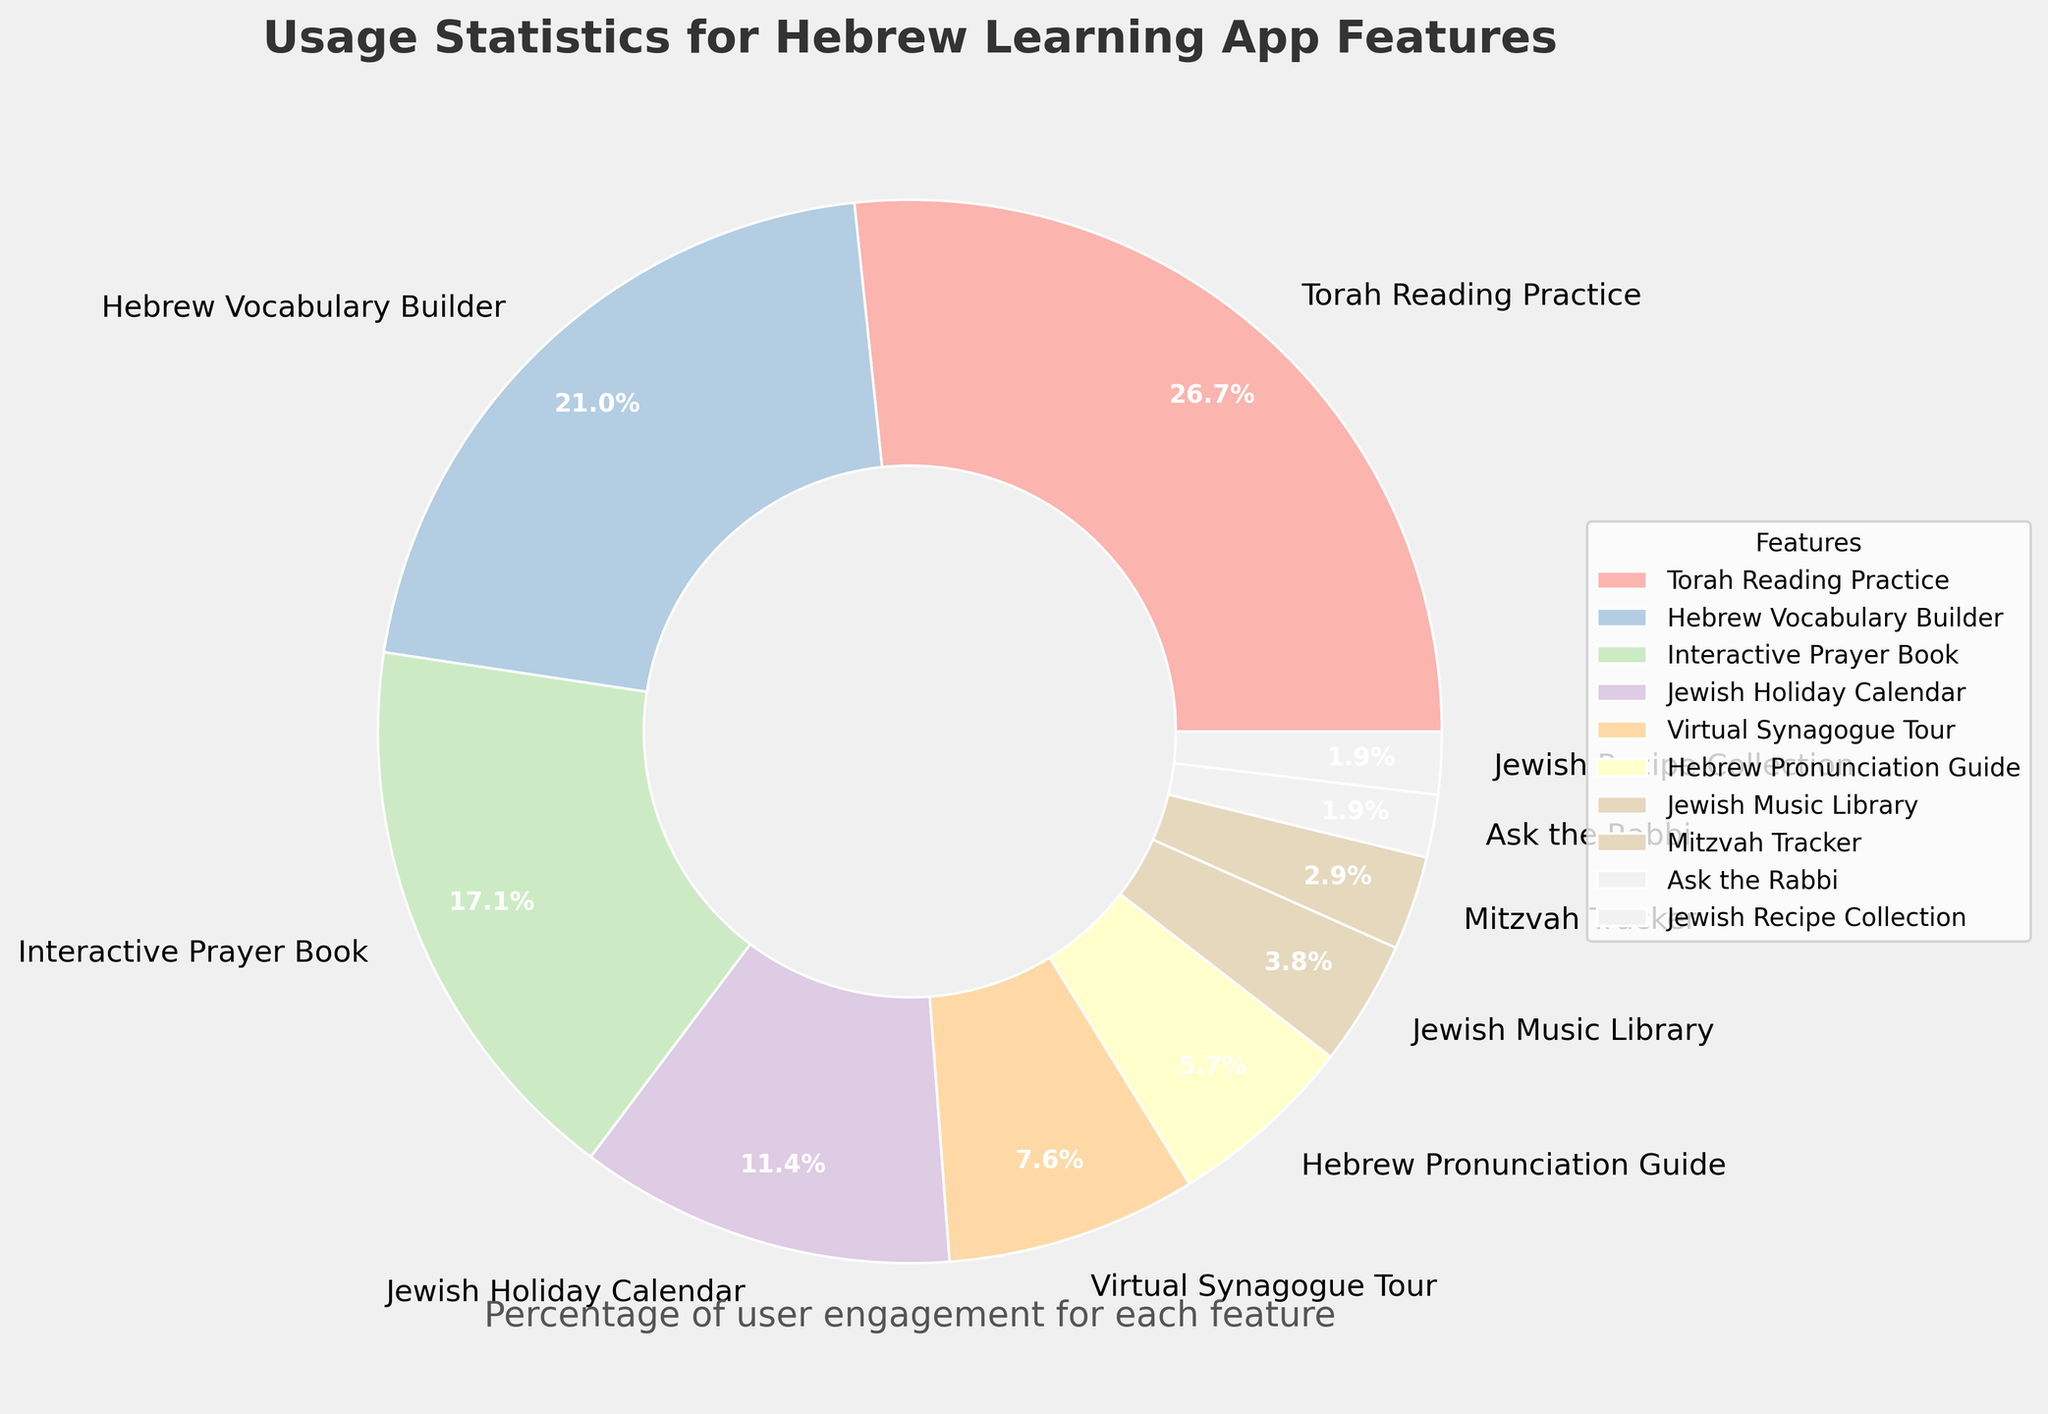Which feature has the highest percentage of user engagement? The feature with the largest slice in the pie chart represents the highest percentage of user engagement.
Answer: Torah Reading Practice Which feature has the lowest percentage of user engagement? The feature with the smallest slice in the pie chart represents the lowest percentage of user engagement.
Answer: Ask the Rabbi, Jewish Recipe Collection How much more usage does the Hebrew Vocabulary Builder have compared to the Jewish Holiday Calendar? According to the percentages, Hebrew Vocabulary Builder has 22% and Jewish Holiday Calendar has 12%. Subtracting these gives the difference. 22% - 12% = 10%
Answer: 10% Is the usage percentage for Torah Reading Practice greater than the combined usage percentage of Jewish Music Library, Mitzvah Tracker, and Ask the Rabbi? First, add the percentages of Jewish Music Library (4%), Mitzvah Tracker (3%), and Ask the Rabbi (2%). 4% + 3% + 2% = 9%. Now, compare this with the Torah Reading Practice percentage, which is 28%. 28% is greater than 9%.
Answer: Yes What two features combined have an overall usage percentage of 28%? Identify two features whose combined percentages add up to 28%. Hebrew Vocabulary Builder (22%) and Jewish Recipe Collection (6%) together make 28%. 22% + 6% = 28%
Answer: Hebrew Vocabulary Builder and Hebrew Pronunciation Guide Which features have a combined usage percentage greater than Torah Reading Practice? Calculate the combined usage percentages of different feature pairs and compare them to 28%. For example, Hebrew Vocabulary Builder (22%) and Interactive Prayer Book (18%) together have a usage of 40%. 22% + 18% = 40%. This is greater than 28%.
Answer: Hebrew Vocabulary Builder and Interactive Prayer Book Rank the top three features by percentage of user engagement. Identify the features with the three largest slices in the pie chart. Torah Reading Practice is the highest (28%), followed by Hebrew Vocabulary Builder (22%), and then Interactive Prayer Book (18%).
Answer: Torah Reading Practice, Hebrew Vocabulary Builder, Interactive Prayer Book How many features have a user engagement percentage below 5%? Count the number of features with slices representing less than 5% in the pie chart. Jewish Music Library (4%), Mitzvah Tracker (3%), Ask the Rabbi (2%), and Jewish Recipe Collection (2%) all fall below 5%. 4 features in total.
Answer: 4 